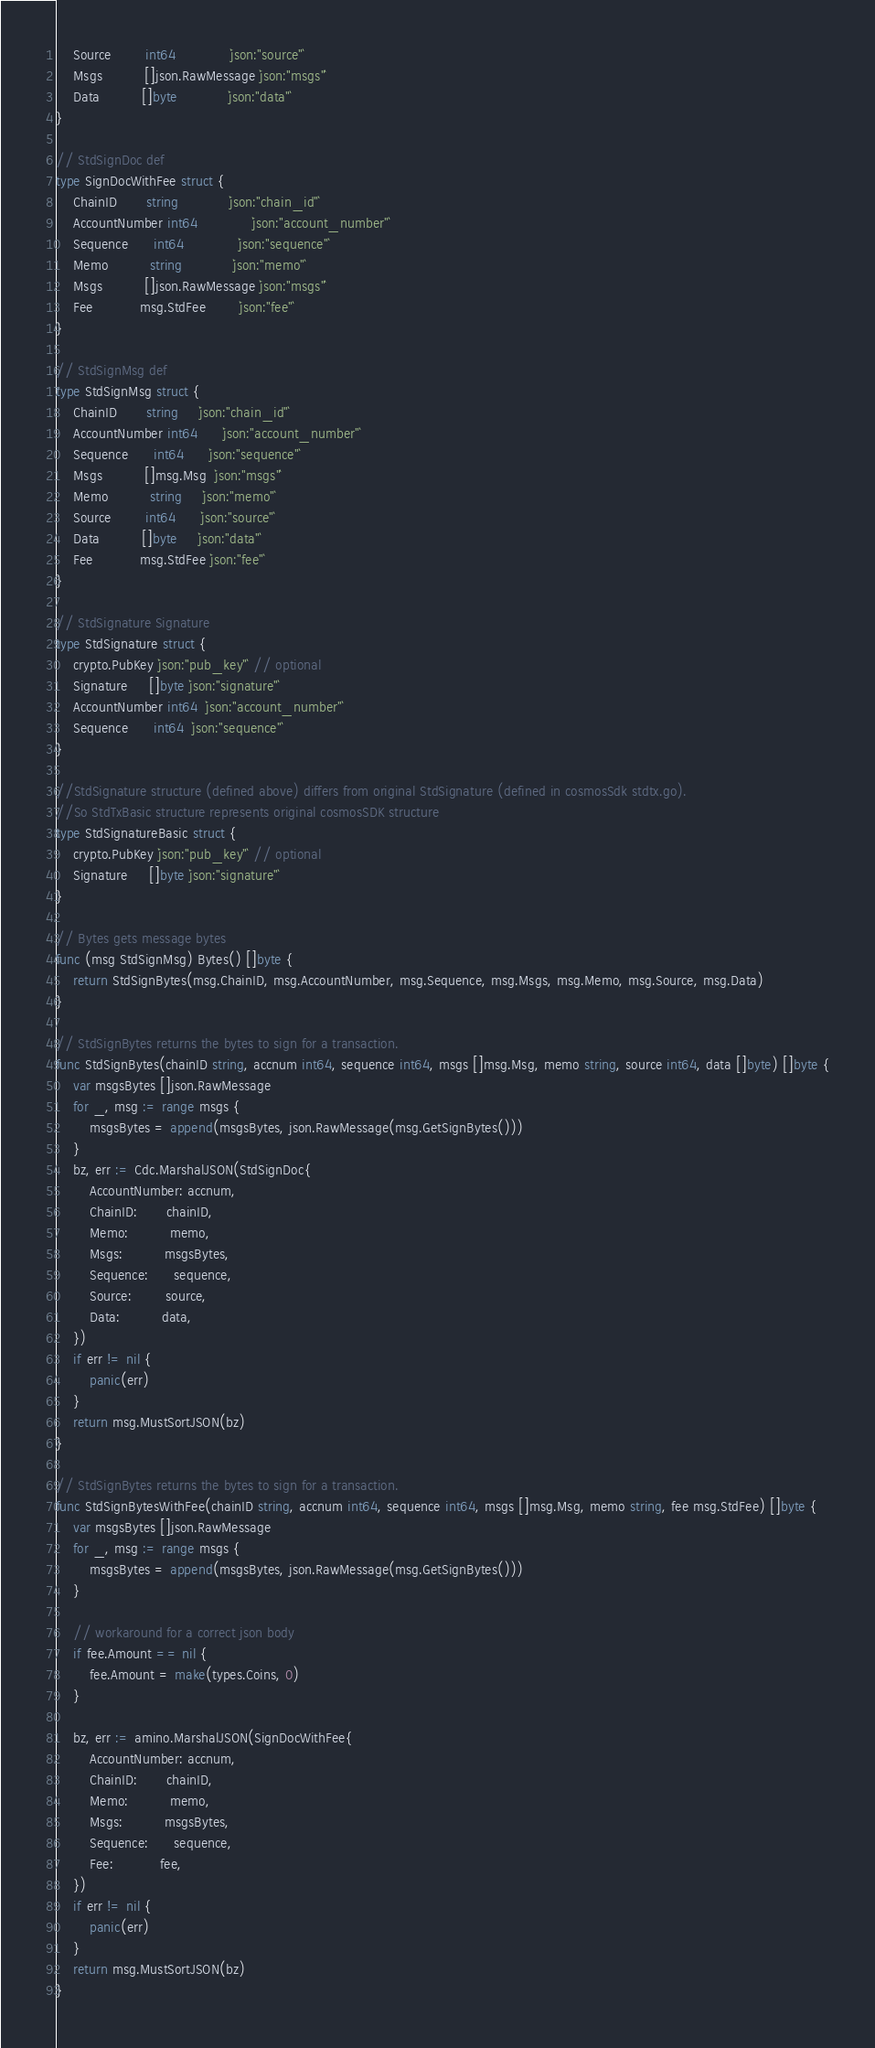<code> <loc_0><loc_0><loc_500><loc_500><_Go_>	Source        int64             `json:"source"`
	Msgs          []json.RawMessage `json:"msgs"`
	Data          []byte            `json:"data"`
}

// StdSignDoc def
type SignDocWithFee struct {
	ChainID       string            `json:"chain_id"`
	AccountNumber int64             `json:"account_number"`
	Sequence      int64             `json:"sequence"`
	Memo          string            `json:"memo"`
	Msgs          []json.RawMessage `json:"msgs"`
	Fee           msg.StdFee        `json:"fee"`
}

// StdSignMsg def
type StdSignMsg struct {
	ChainID       string     `json:"chain_id"`
	AccountNumber int64      `json:"account_number"`
	Sequence      int64      `json:"sequence"`
	Msgs          []msg.Msg  `json:"msgs"`
	Memo          string     `json:"memo"`
	Source        int64      `json:"source"`
	Data          []byte     `json:"data"`
	Fee           msg.StdFee `json:"fee"`
}

// StdSignature Signature
type StdSignature struct {
	crypto.PubKey `json:"pub_key"` // optional
	Signature     []byte `json:"signature"`
	AccountNumber int64  `json:"account_number"`
	Sequence      int64  `json:"sequence"`
}

//StdSignature structure (defined above) differs from original StdSignature (defined in cosmosSdk stdtx.go).
//So StdTxBasic structure represents original cosmosSDK structure
type StdSignatureBasic struct {
	crypto.PubKey `json:"pub_key"` // optional
	Signature     []byte `json:"signature"`
}

// Bytes gets message bytes
func (msg StdSignMsg) Bytes() []byte {
	return StdSignBytes(msg.ChainID, msg.AccountNumber, msg.Sequence, msg.Msgs, msg.Memo, msg.Source, msg.Data)
}

// StdSignBytes returns the bytes to sign for a transaction.
func StdSignBytes(chainID string, accnum int64, sequence int64, msgs []msg.Msg, memo string, source int64, data []byte) []byte {
	var msgsBytes []json.RawMessage
	for _, msg := range msgs {
		msgsBytes = append(msgsBytes, json.RawMessage(msg.GetSignBytes()))
	}
	bz, err := Cdc.MarshalJSON(StdSignDoc{
		AccountNumber: accnum,
		ChainID:       chainID,
		Memo:          memo,
		Msgs:          msgsBytes,
		Sequence:      sequence,
		Source:        source,
		Data:          data,
	})
	if err != nil {
		panic(err)
	}
	return msg.MustSortJSON(bz)
}

// StdSignBytes returns the bytes to sign for a transaction.
func StdSignBytesWithFee(chainID string, accnum int64, sequence int64, msgs []msg.Msg, memo string, fee msg.StdFee) []byte {
	var msgsBytes []json.RawMessage
	for _, msg := range msgs {
		msgsBytes = append(msgsBytes, json.RawMessage(msg.GetSignBytes()))
	}

	// workaround for a correct json body
	if fee.Amount == nil {
		fee.Amount = make(types.Coins, 0)
	}

	bz, err := amino.MarshalJSON(SignDocWithFee{
		AccountNumber: accnum,
		ChainID:       chainID,
		Memo:          memo,
		Msgs:          msgsBytes,
		Sequence:      sequence,
		Fee:           fee,
	})
	if err != nil {
		panic(err)
	}
	return msg.MustSortJSON(bz)
}
</code> 